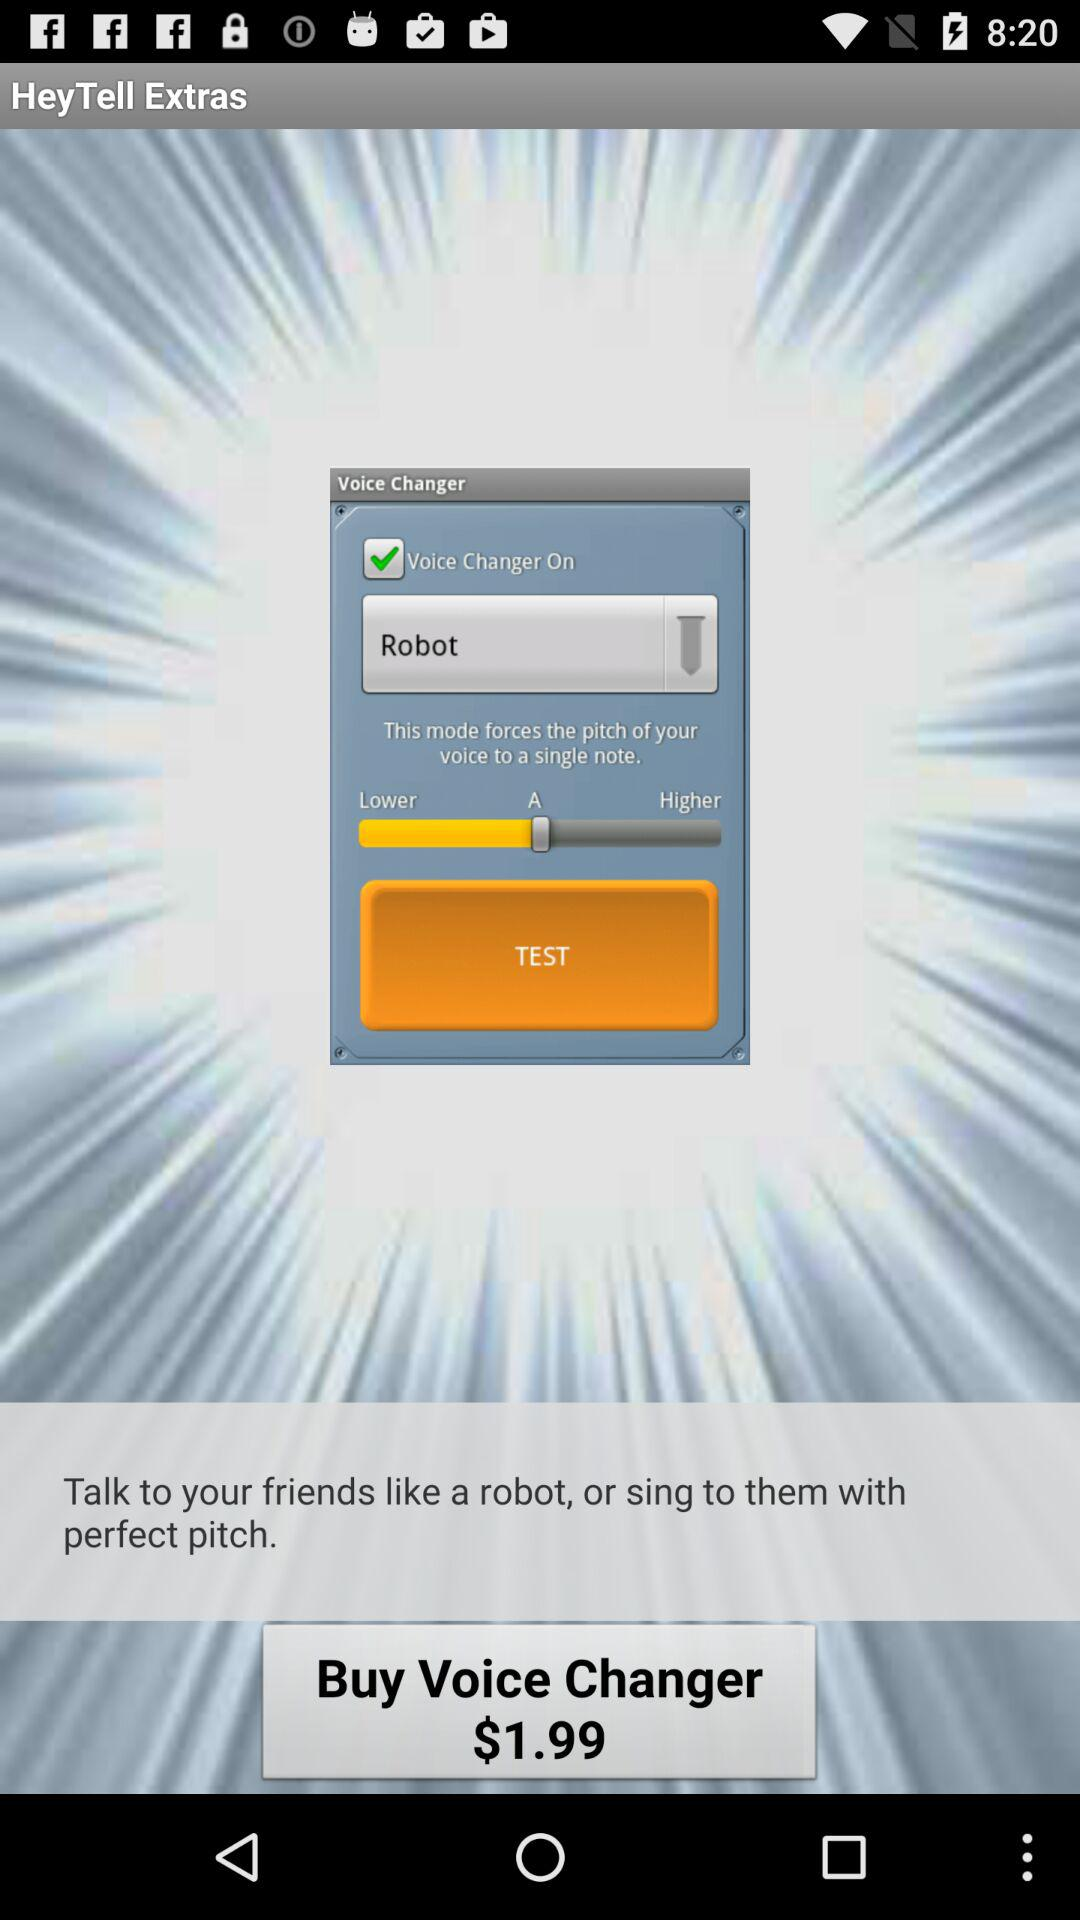What is the status of the "Voice Changer On"? The status is on. 